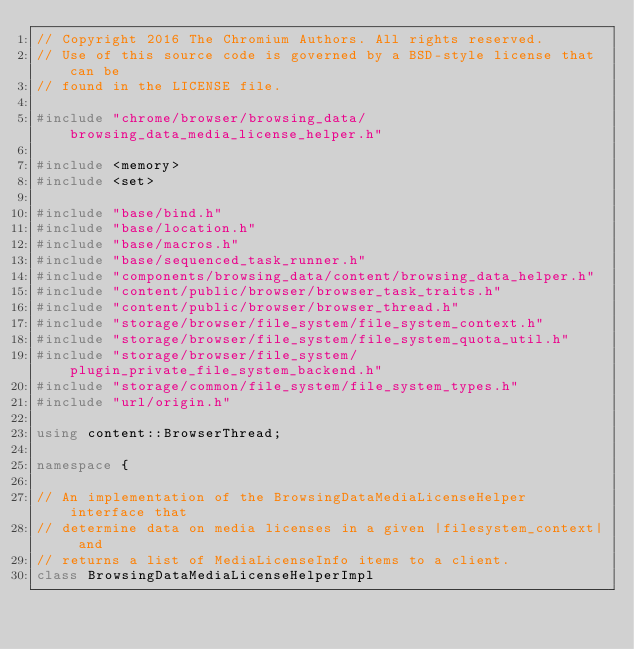<code> <loc_0><loc_0><loc_500><loc_500><_C++_>// Copyright 2016 The Chromium Authors. All rights reserved.
// Use of this source code is governed by a BSD-style license that can be
// found in the LICENSE file.

#include "chrome/browser/browsing_data/browsing_data_media_license_helper.h"

#include <memory>
#include <set>

#include "base/bind.h"
#include "base/location.h"
#include "base/macros.h"
#include "base/sequenced_task_runner.h"
#include "components/browsing_data/content/browsing_data_helper.h"
#include "content/public/browser/browser_task_traits.h"
#include "content/public/browser/browser_thread.h"
#include "storage/browser/file_system/file_system_context.h"
#include "storage/browser/file_system/file_system_quota_util.h"
#include "storage/browser/file_system/plugin_private_file_system_backend.h"
#include "storage/common/file_system/file_system_types.h"
#include "url/origin.h"

using content::BrowserThread;

namespace {

// An implementation of the BrowsingDataMediaLicenseHelper interface that
// determine data on media licenses in a given |filesystem_context| and
// returns a list of MediaLicenseInfo items to a client.
class BrowsingDataMediaLicenseHelperImpl</code> 